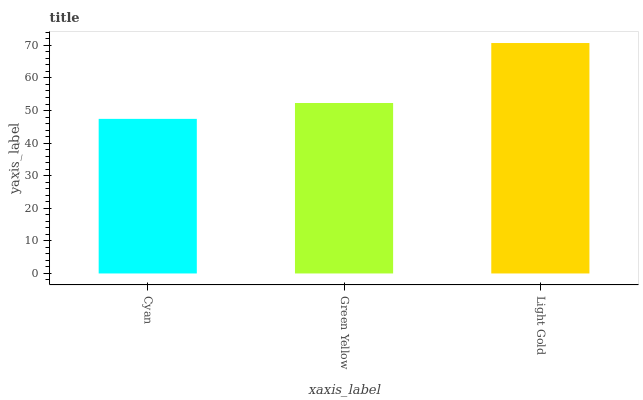Is Cyan the minimum?
Answer yes or no. Yes. Is Light Gold the maximum?
Answer yes or no. Yes. Is Green Yellow the minimum?
Answer yes or no. No. Is Green Yellow the maximum?
Answer yes or no. No. Is Green Yellow greater than Cyan?
Answer yes or no. Yes. Is Cyan less than Green Yellow?
Answer yes or no. Yes. Is Cyan greater than Green Yellow?
Answer yes or no. No. Is Green Yellow less than Cyan?
Answer yes or no. No. Is Green Yellow the high median?
Answer yes or no. Yes. Is Green Yellow the low median?
Answer yes or no. Yes. Is Cyan the high median?
Answer yes or no. No. Is Cyan the low median?
Answer yes or no. No. 